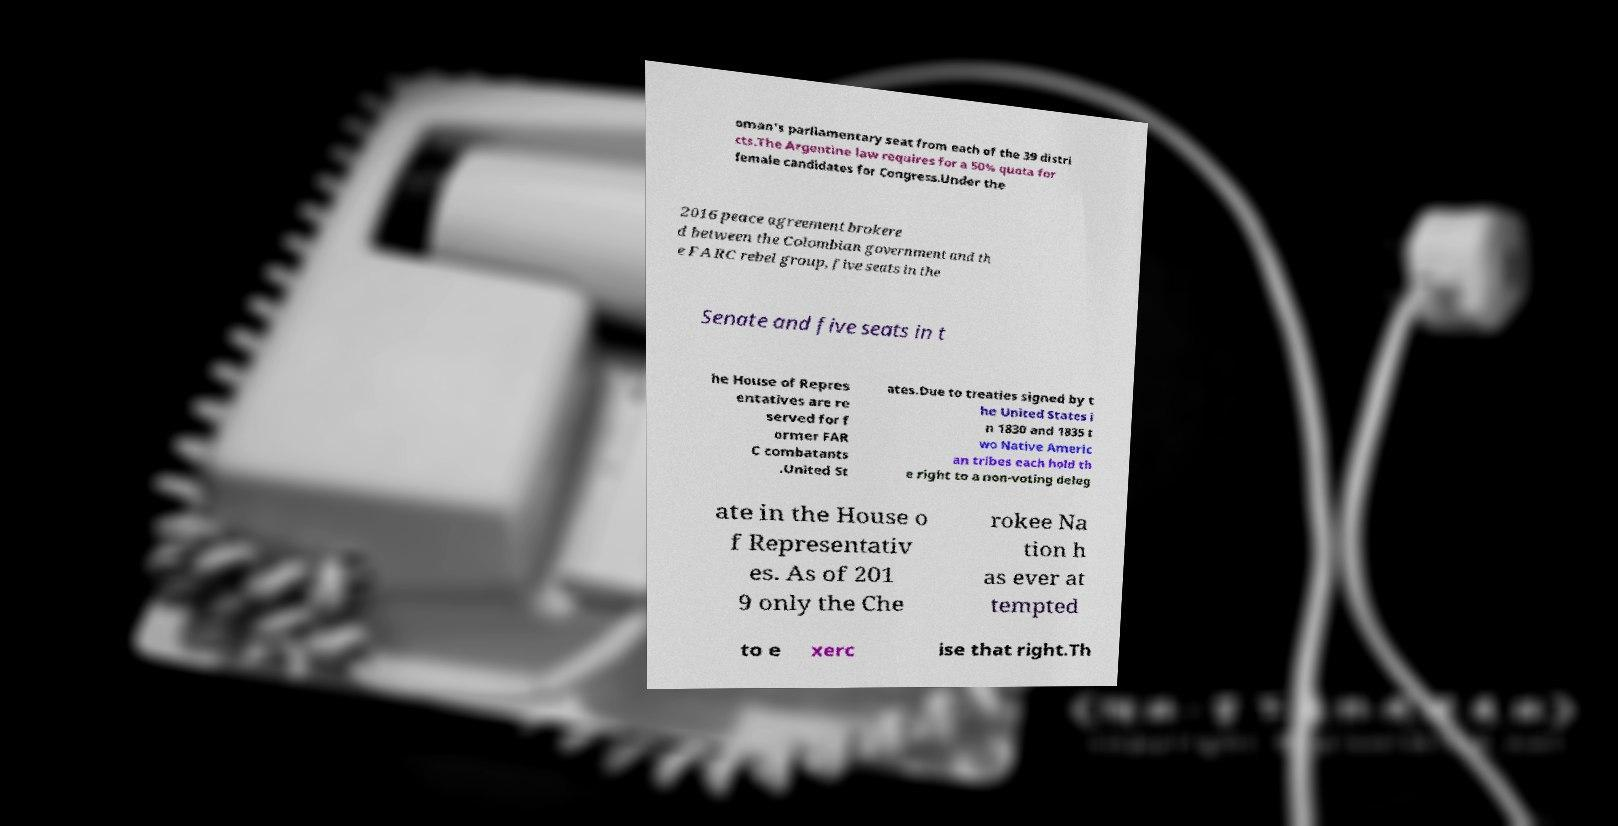Could you assist in decoding the text presented in this image and type it out clearly? oman's parliamentary seat from each of the 39 distri cts.The Argentine law requires for a 50% quota for female candidates for Congress.Under the 2016 peace agreement brokere d between the Colombian government and th e FARC rebel group, five seats in the Senate and five seats in t he House of Repres entatives are re served for f ormer FAR C combatants .United St ates.Due to treaties signed by t he United States i n 1830 and 1835 t wo Native Americ an tribes each hold th e right to a non-voting deleg ate in the House o f Representativ es. As of 201 9 only the Che rokee Na tion h as ever at tempted to e xerc ise that right.Th 